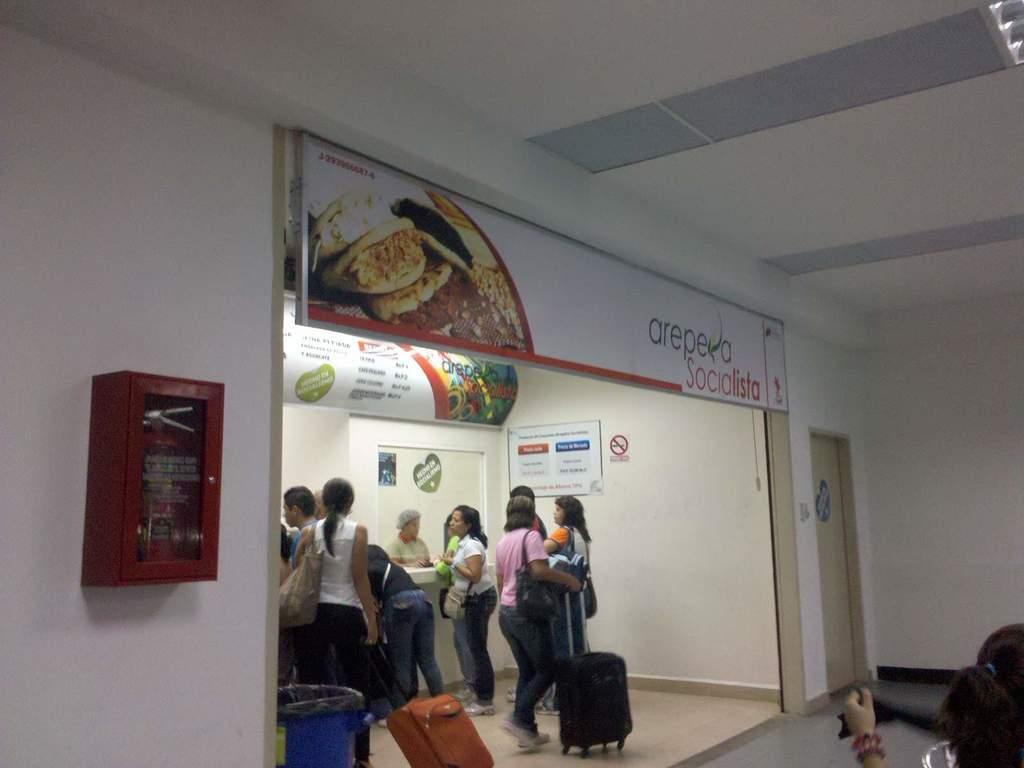How would you summarize this image in a sentence or two? On the right side of the image there is a person. There is a poster on the closed door. There are people holding the luggages. In front of them there is a table. Behind the table there is a person. Behind the person there are posters on the door and a wall. There are boards with some text and pictures on it. On the left side of the image there is some object on the wall. On top of the image there is a light. 